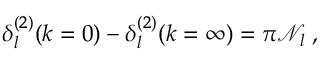<formula> <loc_0><loc_0><loc_500><loc_500>\delta _ { l } ^ { ( 2 ) } ( k = 0 ) - \delta _ { l } ^ { ( 2 ) } ( k = \infty ) = \pi { \mathcal { N } } _ { l } \, ,</formula> 